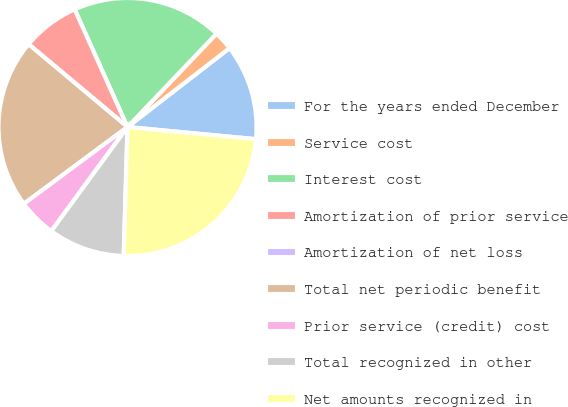Convert chart to OTSL. <chart><loc_0><loc_0><loc_500><loc_500><pie_chart><fcel>For the years ended December<fcel>Service cost<fcel>Interest cost<fcel>Amortization of prior service<fcel>Amortization of net loss<fcel>Total net periodic benefit<fcel>Prior service (credit) cost<fcel>Total recognized in other<fcel>Net amounts recognized in<nl><fcel>11.98%<fcel>2.4%<fcel>18.84%<fcel>7.19%<fcel>0.0%<fcel>21.24%<fcel>4.79%<fcel>9.59%<fcel>23.97%<nl></chart> 